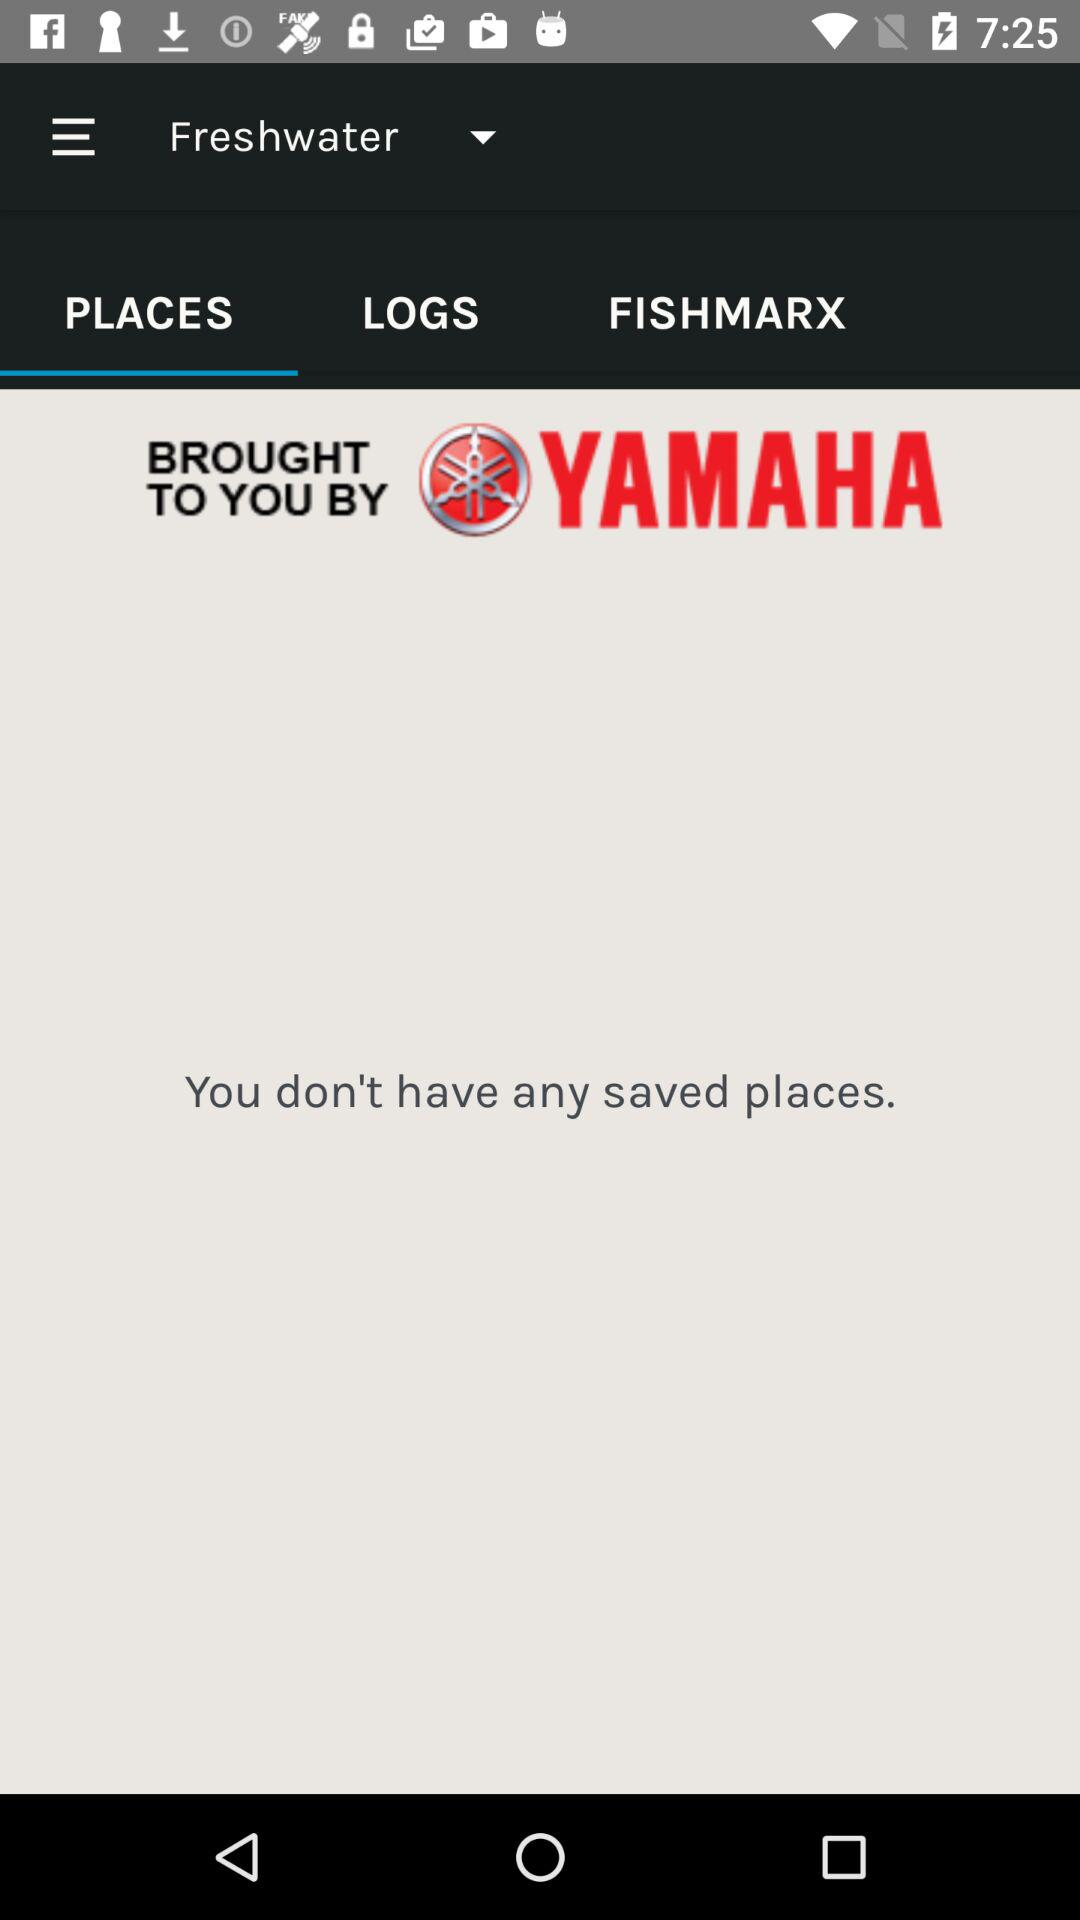How many items are in "LOGS"?
When the provided information is insufficient, respond with <no answer>. <no answer> 